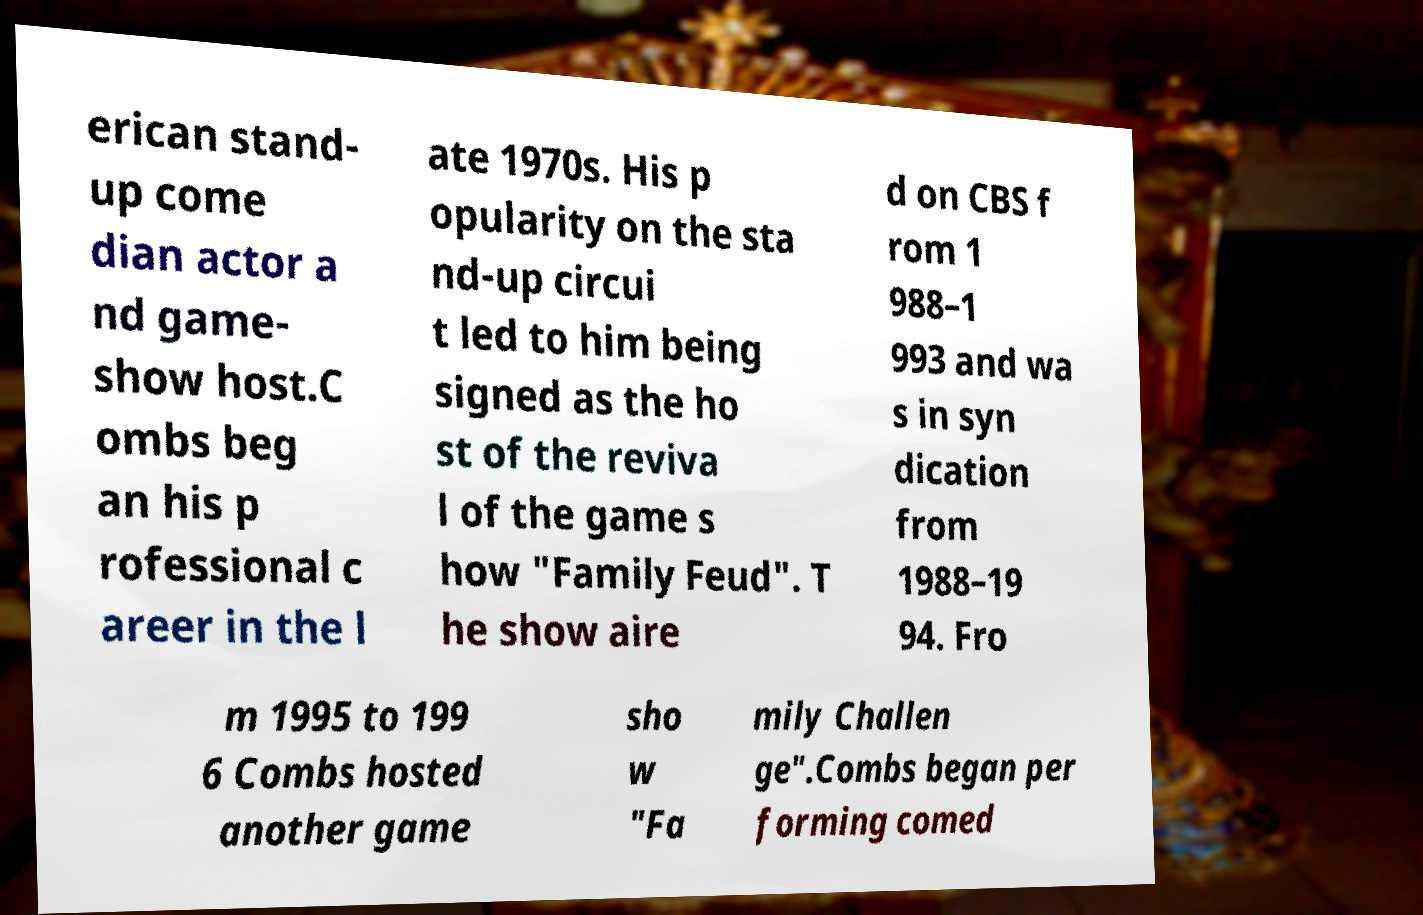Could you extract and type out the text from this image? erican stand- up come dian actor a nd game- show host.C ombs beg an his p rofessional c areer in the l ate 1970s. His p opularity on the sta nd-up circui t led to him being signed as the ho st of the reviva l of the game s how "Family Feud". T he show aire d on CBS f rom 1 988–1 993 and wa s in syn dication from 1988–19 94. Fro m 1995 to 199 6 Combs hosted another game sho w "Fa mily Challen ge".Combs began per forming comed 